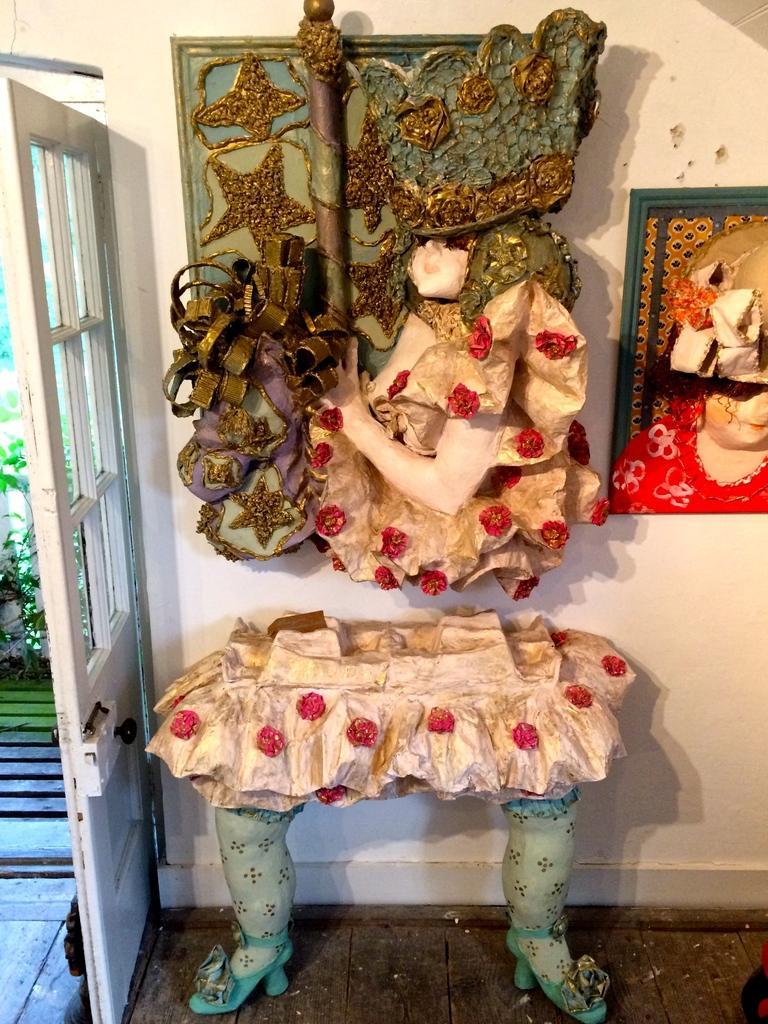Please provide a concise description of this image. In this picture we can see a table in the form of the legs of a person. There are sculptures on the wall. We can see a door with a door handle, leaves and other objects. 